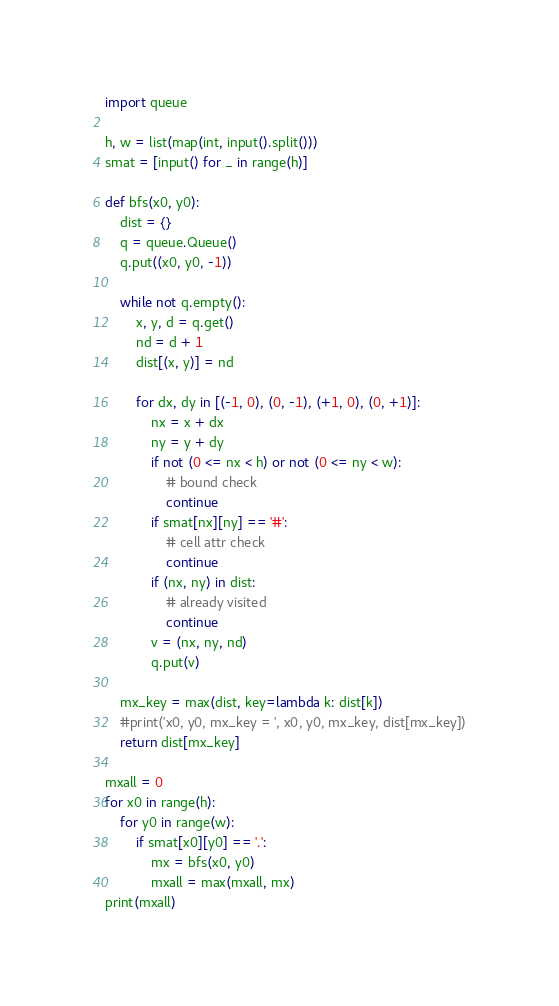Convert code to text. <code><loc_0><loc_0><loc_500><loc_500><_Python_>import queue

h, w = list(map(int, input().split()))
smat = [input() for _ in range(h)]

def bfs(x0, y0):
    dist = {}
    q = queue.Queue()
    q.put((x0, y0, -1))

    while not q.empty():
        x, y, d = q.get()
        nd = d + 1
        dist[(x, y)] = nd

        for dx, dy in [(-1, 0), (0, -1), (+1, 0), (0, +1)]:
            nx = x + dx
            ny = y + dy
            if not (0 <= nx < h) or not (0 <= ny < w):
                # bound check
                continue
            if smat[nx][ny] == '#':
                # cell attr check
                continue
            if (nx, ny) in dist:
                # already visited
                continue
            v = (nx, ny, nd)
            q.put(v)
    
    mx_key = max(dist, key=lambda k: dist[k])
    #print('x0, y0, mx_key = ', x0, y0, mx_key, dist[mx_key])
    return dist[mx_key]

mxall = 0
for x0 in range(h):
    for y0 in range(w):
        if smat[x0][y0] == '.':
            mx = bfs(x0, y0)
            mxall = max(mxall, mx)
print(mxall)
</code> 